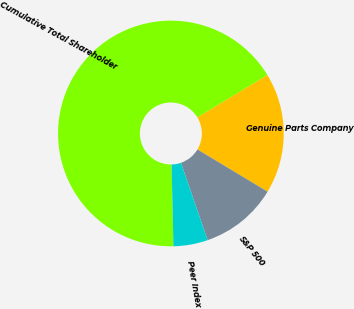Convert chart. <chart><loc_0><loc_0><loc_500><loc_500><pie_chart><fcel>Cumulative Total Shareholder<fcel>Genuine Parts Company<fcel>S&P 500<fcel>Peer Index<nl><fcel>66.7%<fcel>17.28%<fcel>11.1%<fcel>4.92%<nl></chart> 